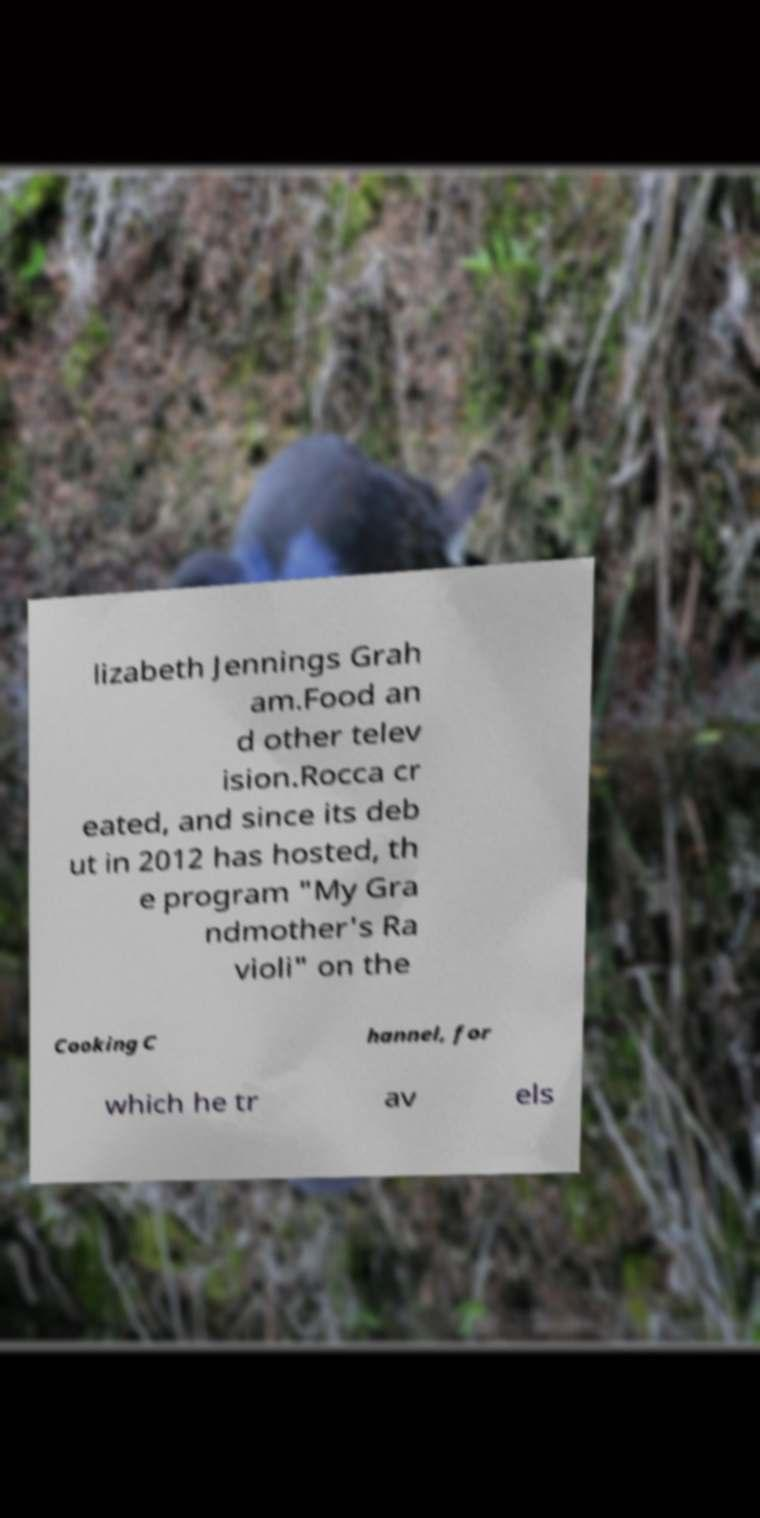Please identify and transcribe the text found in this image. lizabeth Jennings Grah am.Food an d other telev ision.Rocca cr eated, and since its deb ut in 2012 has hosted, th e program "My Gra ndmother's Ra violi" on the Cooking C hannel, for which he tr av els 